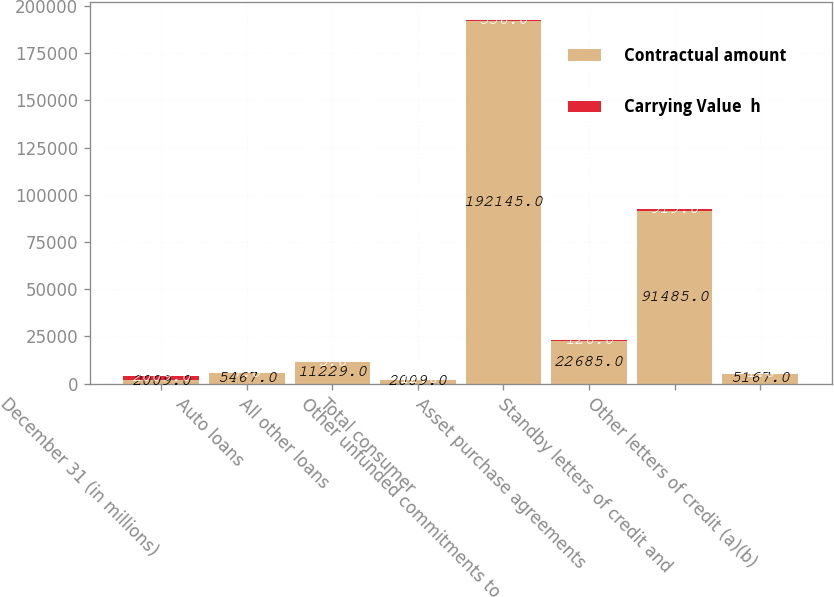<chart> <loc_0><loc_0><loc_500><loc_500><stacked_bar_chart><ecel><fcel>December 31 (in millions)<fcel>Auto loans<fcel>All other loans<fcel>Total consumer<fcel>Other unfunded commitments to<fcel>Asset purchase agreements<fcel>Standby letters of credit and<fcel>Other letters of credit (a)(b)<nl><fcel>Contractual amount<fcel>2009<fcel>5467<fcel>11229<fcel>2009<fcel>192145<fcel>22685<fcel>91485<fcel>5167<nl><fcel>Carrying Value  h<fcel>2009<fcel>7<fcel>5<fcel>12<fcel>356<fcel>126<fcel>919<fcel>1<nl></chart> 